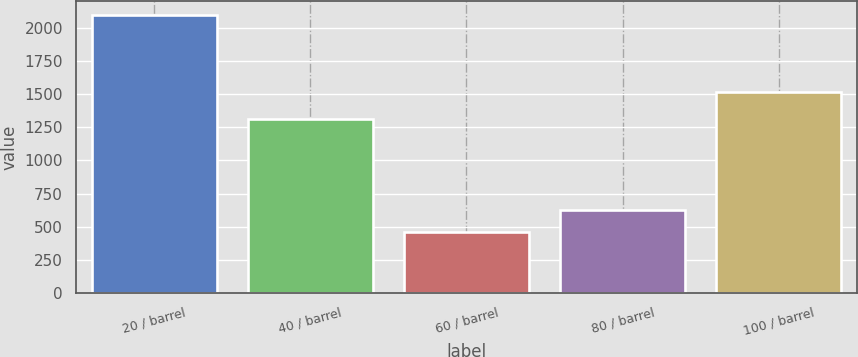<chart> <loc_0><loc_0><loc_500><loc_500><bar_chart><fcel>20 / barrel<fcel>40 / barrel<fcel>60 / barrel<fcel>80 / barrel<fcel>100 / barrel<nl><fcel>2101<fcel>1312<fcel>462<fcel>625.9<fcel>1519<nl></chart> 